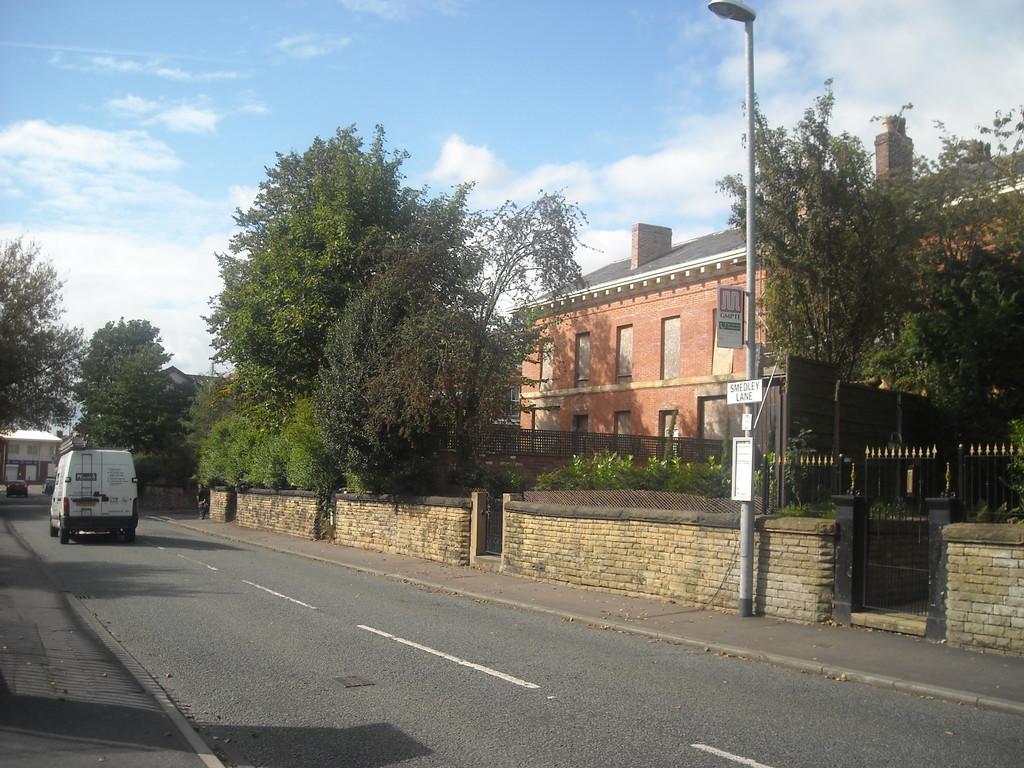Please provide a concise description of this image. In this image I can see the vehicle on the road. To the right I can see the pole and the boards attached to the pole. In the background I can see many trees, buildings, clouds and the sky. 